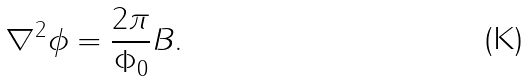<formula> <loc_0><loc_0><loc_500><loc_500>\nabla ^ { 2 } \phi = \frac { 2 \pi } { \Phi _ { 0 } } B .</formula> 